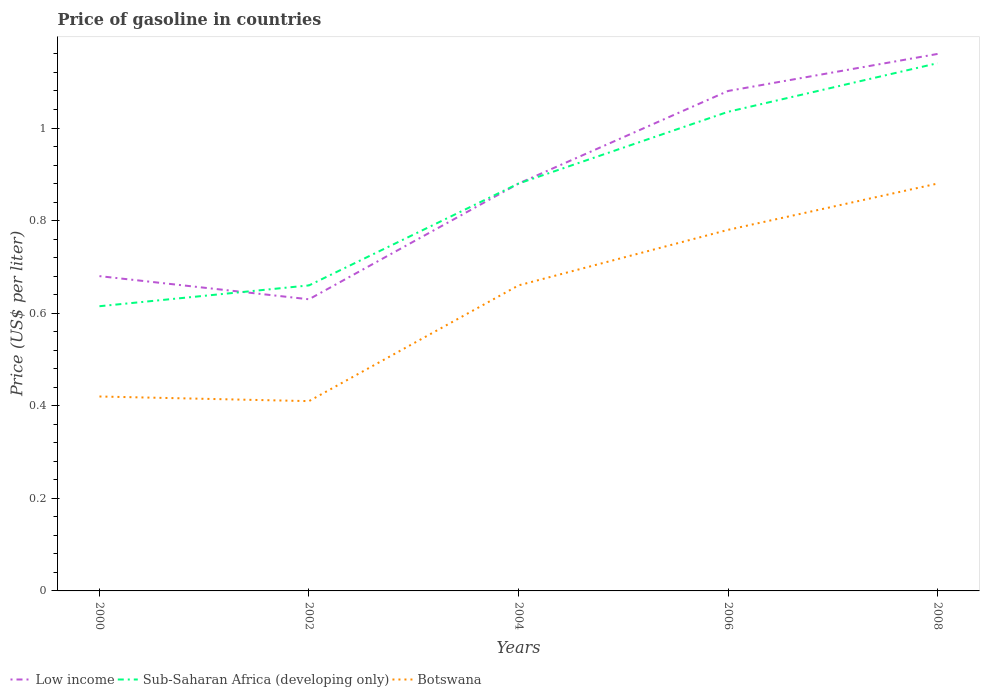Does the line corresponding to Botswana intersect with the line corresponding to Low income?
Offer a very short reply. No. Is the number of lines equal to the number of legend labels?
Keep it short and to the point. Yes. Across all years, what is the maximum price of gasoline in Sub-Saharan Africa (developing only)?
Your response must be concise. 0.61. What is the total price of gasoline in Sub-Saharan Africa (developing only) in the graph?
Keep it short and to the point. -0.05. What is the difference between the highest and the second highest price of gasoline in Sub-Saharan Africa (developing only)?
Provide a succinct answer. 0.52. What is the difference between the highest and the lowest price of gasoline in Sub-Saharan Africa (developing only)?
Your answer should be compact. 3. How many lines are there?
Ensure brevity in your answer.  3. What is the difference between two consecutive major ticks on the Y-axis?
Your response must be concise. 0.2. Where does the legend appear in the graph?
Your answer should be very brief. Bottom left. How are the legend labels stacked?
Your response must be concise. Horizontal. What is the title of the graph?
Your answer should be very brief. Price of gasoline in countries. What is the label or title of the X-axis?
Your response must be concise. Years. What is the label or title of the Y-axis?
Your answer should be very brief. Price (US$ per liter). What is the Price (US$ per liter) of Low income in 2000?
Your response must be concise. 0.68. What is the Price (US$ per liter) in Sub-Saharan Africa (developing only) in 2000?
Offer a terse response. 0.61. What is the Price (US$ per liter) of Botswana in 2000?
Make the answer very short. 0.42. What is the Price (US$ per liter) of Low income in 2002?
Give a very brief answer. 0.63. What is the Price (US$ per liter) of Sub-Saharan Africa (developing only) in 2002?
Your answer should be compact. 0.66. What is the Price (US$ per liter) in Botswana in 2002?
Provide a short and direct response. 0.41. What is the Price (US$ per liter) of Low income in 2004?
Provide a succinct answer. 0.88. What is the Price (US$ per liter) in Sub-Saharan Africa (developing only) in 2004?
Your response must be concise. 0.88. What is the Price (US$ per liter) in Botswana in 2004?
Ensure brevity in your answer.  0.66. What is the Price (US$ per liter) in Low income in 2006?
Keep it short and to the point. 1.08. What is the Price (US$ per liter) of Sub-Saharan Africa (developing only) in 2006?
Your answer should be compact. 1.03. What is the Price (US$ per liter) of Botswana in 2006?
Offer a very short reply. 0.78. What is the Price (US$ per liter) in Low income in 2008?
Keep it short and to the point. 1.16. What is the Price (US$ per liter) of Sub-Saharan Africa (developing only) in 2008?
Offer a terse response. 1.14. Across all years, what is the maximum Price (US$ per liter) of Low income?
Ensure brevity in your answer.  1.16. Across all years, what is the maximum Price (US$ per liter) of Sub-Saharan Africa (developing only)?
Provide a short and direct response. 1.14. Across all years, what is the minimum Price (US$ per liter) of Low income?
Your answer should be very brief. 0.63. Across all years, what is the minimum Price (US$ per liter) in Sub-Saharan Africa (developing only)?
Give a very brief answer. 0.61. Across all years, what is the minimum Price (US$ per liter) of Botswana?
Keep it short and to the point. 0.41. What is the total Price (US$ per liter) in Low income in the graph?
Provide a short and direct response. 4.43. What is the total Price (US$ per liter) of Sub-Saharan Africa (developing only) in the graph?
Provide a short and direct response. 4.33. What is the total Price (US$ per liter) of Botswana in the graph?
Offer a terse response. 3.15. What is the difference between the Price (US$ per liter) in Sub-Saharan Africa (developing only) in 2000 and that in 2002?
Offer a terse response. -0.04. What is the difference between the Price (US$ per liter) in Botswana in 2000 and that in 2002?
Provide a short and direct response. 0.01. What is the difference between the Price (US$ per liter) of Sub-Saharan Africa (developing only) in 2000 and that in 2004?
Ensure brevity in your answer.  -0.27. What is the difference between the Price (US$ per liter) in Botswana in 2000 and that in 2004?
Keep it short and to the point. -0.24. What is the difference between the Price (US$ per liter) of Low income in 2000 and that in 2006?
Offer a very short reply. -0.4. What is the difference between the Price (US$ per liter) of Sub-Saharan Africa (developing only) in 2000 and that in 2006?
Make the answer very short. -0.42. What is the difference between the Price (US$ per liter) in Botswana in 2000 and that in 2006?
Give a very brief answer. -0.36. What is the difference between the Price (US$ per liter) of Low income in 2000 and that in 2008?
Ensure brevity in your answer.  -0.48. What is the difference between the Price (US$ per liter) in Sub-Saharan Africa (developing only) in 2000 and that in 2008?
Offer a very short reply. -0.53. What is the difference between the Price (US$ per liter) of Botswana in 2000 and that in 2008?
Provide a succinct answer. -0.46. What is the difference between the Price (US$ per liter) in Sub-Saharan Africa (developing only) in 2002 and that in 2004?
Give a very brief answer. -0.22. What is the difference between the Price (US$ per liter) in Low income in 2002 and that in 2006?
Your answer should be compact. -0.45. What is the difference between the Price (US$ per liter) of Sub-Saharan Africa (developing only) in 2002 and that in 2006?
Keep it short and to the point. -0.38. What is the difference between the Price (US$ per liter) of Botswana in 2002 and that in 2006?
Make the answer very short. -0.37. What is the difference between the Price (US$ per liter) in Low income in 2002 and that in 2008?
Your answer should be compact. -0.53. What is the difference between the Price (US$ per liter) in Sub-Saharan Africa (developing only) in 2002 and that in 2008?
Your response must be concise. -0.48. What is the difference between the Price (US$ per liter) of Botswana in 2002 and that in 2008?
Provide a short and direct response. -0.47. What is the difference between the Price (US$ per liter) in Low income in 2004 and that in 2006?
Your response must be concise. -0.2. What is the difference between the Price (US$ per liter) in Sub-Saharan Africa (developing only) in 2004 and that in 2006?
Keep it short and to the point. -0.15. What is the difference between the Price (US$ per liter) of Botswana in 2004 and that in 2006?
Give a very brief answer. -0.12. What is the difference between the Price (US$ per liter) of Low income in 2004 and that in 2008?
Provide a short and direct response. -0.28. What is the difference between the Price (US$ per liter) in Sub-Saharan Africa (developing only) in 2004 and that in 2008?
Offer a very short reply. -0.26. What is the difference between the Price (US$ per liter) in Botswana in 2004 and that in 2008?
Provide a succinct answer. -0.22. What is the difference between the Price (US$ per liter) of Low income in 2006 and that in 2008?
Your response must be concise. -0.08. What is the difference between the Price (US$ per liter) of Sub-Saharan Africa (developing only) in 2006 and that in 2008?
Offer a very short reply. -0.1. What is the difference between the Price (US$ per liter) of Botswana in 2006 and that in 2008?
Offer a very short reply. -0.1. What is the difference between the Price (US$ per liter) in Low income in 2000 and the Price (US$ per liter) in Sub-Saharan Africa (developing only) in 2002?
Your answer should be compact. 0.02. What is the difference between the Price (US$ per liter) of Low income in 2000 and the Price (US$ per liter) of Botswana in 2002?
Make the answer very short. 0.27. What is the difference between the Price (US$ per liter) of Sub-Saharan Africa (developing only) in 2000 and the Price (US$ per liter) of Botswana in 2002?
Your answer should be very brief. 0.2. What is the difference between the Price (US$ per liter) in Low income in 2000 and the Price (US$ per liter) in Botswana in 2004?
Ensure brevity in your answer.  0.02. What is the difference between the Price (US$ per liter) in Sub-Saharan Africa (developing only) in 2000 and the Price (US$ per liter) in Botswana in 2004?
Keep it short and to the point. -0.04. What is the difference between the Price (US$ per liter) of Low income in 2000 and the Price (US$ per liter) of Sub-Saharan Africa (developing only) in 2006?
Provide a short and direct response. -0.35. What is the difference between the Price (US$ per liter) of Low income in 2000 and the Price (US$ per liter) of Botswana in 2006?
Provide a succinct answer. -0.1. What is the difference between the Price (US$ per liter) of Sub-Saharan Africa (developing only) in 2000 and the Price (US$ per liter) of Botswana in 2006?
Provide a succinct answer. -0.17. What is the difference between the Price (US$ per liter) in Low income in 2000 and the Price (US$ per liter) in Sub-Saharan Africa (developing only) in 2008?
Provide a succinct answer. -0.46. What is the difference between the Price (US$ per liter) in Sub-Saharan Africa (developing only) in 2000 and the Price (US$ per liter) in Botswana in 2008?
Provide a short and direct response. -0.27. What is the difference between the Price (US$ per liter) in Low income in 2002 and the Price (US$ per liter) in Sub-Saharan Africa (developing only) in 2004?
Your answer should be compact. -0.25. What is the difference between the Price (US$ per liter) in Low income in 2002 and the Price (US$ per liter) in Botswana in 2004?
Give a very brief answer. -0.03. What is the difference between the Price (US$ per liter) in Low income in 2002 and the Price (US$ per liter) in Sub-Saharan Africa (developing only) in 2006?
Make the answer very short. -0.41. What is the difference between the Price (US$ per liter) in Low income in 2002 and the Price (US$ per liter) in Botswana in 2006?
Your response must be concise. -0.15. What is the difference between the Price (US$ per liter) in Sub-Saharan Africa (developing only) in 2002 and the Price (US$ per liter) in Botswana in 2006?
Make the answer very short. -0.12. What is the difference between the Price (US$ per liter) in Low income in 2002 and the Price (US$ per liter) in Sub-Saharan Africa (developing only) in 2008?
Offer a terse response. -0.51. What is the difference between the Price (US$ per liter) in Low income in 2002 and the Price (US$ per liter) in Botswana in 2008?
Give a very brief answer. -0.25. What is the difference between the Price (US$ per liter) in Sub-Saharan Africa (developing only) in 2002 and the Price (US$ per liter) in Botswana in 2008?
Offer a terse response. -0.22. What is the difference between the Price (US$ per liter) in Low income in 2004 and the Price (US$ per liter) in Sub-Saharan Africa (developing only) in 2006?
Your answer should be very brief. -0.15. What is the difference between the Price (US$ per liter) in Sub-Saharan Africa (developing only) in 2004 and the Price (US$ per liter) in Botswana in 2006?
Ensure brevity in your answer.  0.1. What is the difference between the Price (US$ per liter) in Low income in 2004 and the Price (US$ per liter) in Sub-Saharan Africa (developing only) in 2008?
Your answer should be very brief. -0.26. What is the difference between the Price (US$ per liter) in Low income in 2004 and the Price (US$ per liter) in Botswana in 2008?
Your answer should be very brief. 0. What is the difference between the Price (US$ per liter) of Low income in 2006 and the Price (US$ per liter) of Sub-Saharan Africa (developing only) in 2008?
Your answer should be very brief. -0.06. What is the difference between the Price (US$ per liter) of Low income in 2006 and the Price (US$ per liter) of Botswana in 2008?
Keep it short and to the point. 0.2. What is the difference between the Price (US$ per liter) in Sub-Saharan Africa (developing only) in 2006 and the Price (US$ per liter) in Botswana in 2008?
Your response must be concise. 0.15. What is the average Price (US$ per liter) in Low income per year?
Keep it short and to the point. 0.89. What is the average Price (US$ per liter) in Sub-Saharan Africa (developing only) per year?
Offer a very short reply. 0.87. What is the average Price (US$ per liter) in Botswana per year?
Your answer should be very brief. 0.63. In the year 2000, what is the difference between the Price (US$ per liter) in Low income and Price (US$ per liter) in Sub-Saharan Africa (developing only)?
Make the answer very short. 0.07. In the year 2000, what is the difference between the Price (US$ per liter) of Low income and Price (US$ per liter) of Botswana?
Provide a succinct answer. 0.26. In the year 2000, what is the difference between the Price (US$ per liter) in Sub-Saharan Africa (developing only) and Price (US$ per liter) in Botswana?
Offer a very short reply. 0.2. In the year 2002, what is the difference between the Price (US$ per liter) in Low income and Price (US$ per liter) in Sub-Saharan Africa (developing only)?
Ensure brevity in your answer.  -0.03. In the year 2002, what is the difference between the Price (US$ per liter) in Low income and Price (US$ per liter) in Botswana?
Provide a short and direct response. 0.22. In the year 2002, what is the difference between the Price (US$ per liter) of Sub-Saharan Africa (developing only) and Price (US$ per liter) of Botswana?
Your answer should be very brief. 0.25. In the year 2004, what is the difference between the Price (US$ per liter) in Low income and Price (US$ per liter) in Sub-Saharan Africa (developing only)?
Give a very brief answer. 0. In the year 2004, what is the difference between the Price (US$ per liter) of Low income and Price (US$ per liter) of Botswana?
Offer a terse response. 0.22. In the year 2004, what is the difference between the Price (US$ per liter) in Sub-Saharan Africa (developing only) and Price (US$ per liter) in Botswana?
Keep it short and to the point. 0.22. In the year 2006, what is the difference between the Price (US$ per liter) in Low income and Price (US$ per liter) in Sub-Saharan Africa (developing only)?
Your response must be concise. 0.04. In the year 2006, what is the difference between the Price (US$ per liter) of Sub-Saharan Africa (developing only) and Price (US$ per liter) of Botswana?
Keep it short and to the point. 0.26. In the year 2008, what is the difference between the Price (US$ per liter) of Low income and Price (US$ per liter) of Botswana?
Offer a very short reply. 0.28. In the year 2008, what is the difference between the Price (US$ per liter) in Sub-Saharan Africa (developing only) and Price (US$ per liter) in Botswana?
Make the answer very short. 0.26. What is the ratio of the Price (US$ per liter) in Low income in 2000 to that in 2002?
Your answer should be compact. 1.08. What is the ratio of the Price (US$ per liter) of Sub-Saharan Africa (developing only) in 2000 to that in 2002?
Offer a very short reply. 0.93. What is the ratio of the Price (US$ per liter) in Botswana in 2000 to that in 2002?
Offer a terse response. 1.02. What is the ratio of the Price (US$ per liter) of Low income in 2000 to that in 2004?
Provide a succinct answer. 0.77. What is the ratio of the Price (US$ per liter) in Sub-Saharan Africa (developing only) in 2000 to that in 2004?
Make the answer very short. 0.7. What is the ratio of the Price (US$ per liter) of Botswana in 2000 to that in 2004?
Give a very brief answer. 0.64. What is the ratio of the Price (US$ per liter) of Low income in 2000 to that in 2006?
Make the answer very short. 0.63. What is the ratio of the Price (US$ per liter) in Sub-Saharan Africa (developing only) in 2000 to that in 2006?
Ensure brevity in your answer.  0.59. What is the ratio of the Price (US$ per liter) of Botswana in 2000 to that in 2006?
Keep it short and to the point. 0.54. What is the ratio of the Price (US$ per liter) in Low income in 2000 to that in 2008?
Your answer should be compact. 0.59. What is the ratio of the Price (US$ per liter) in Sub-Saharan Africa (developing only) in 2000 to that in 2008?
Offer a terse response. 0.54. What is the ratio of the Price (US$ per liter) in Botswana in 2000 to that in 2008?
Provide a succinct answer. 0.48. What is the ratio of the Price (US$ per liter) of Low income in 2002 to that in 2004?
Your response must be concise. 0.72. What is the ratio of the Price (US$ per liter) in Botswana in 2002 to that in 2004?
Ensure brevity in your answer.  0.62. What is the ratio of the Price (US$ per liter) of Low income in 2002 to that in 2006?
Provide a succinct answer. 0.58. What is the ratio of the Price (US$ per liter) of Sub-Saharan Africa (developing only) in 2002 to that in 2006?
Offer a very short reply. 0.64. What is the ratio of the Price (US$ per liter) in Botswana in 2002 to that in 2006?
Offer a terse response. 0.53. What is the ratio of the Price (US$ per liter) in Low income in 2002 to that in 2008?
Your answer should be very brief. 0.54. What is the ratio of the Price (US$ per liter) in Sub-Saharan Africa (developing only) in 2002 to that in 2008?
Your answer should be very brief. 0.58. What is the ratio of the Price (US$ per liter) of Botswana in 2002 to that in 2008?
Provide a succinct answer. 0.47. What is the ratio of the Price (US$ per liter) of Low income in 2004 to that in 2006?
Your answer should be compact. 0.81. What is the ratio of the Price (US$ per liter) of Sub-Saharan Africa (developing only) in 2004 to that in 2006?
Offer a very short reply. 0.85. What is the ratio of the Price (US$ per liter) of Botswana in 2004 to that in 2006?
Ensure brevity in your answer.  0.85. What is the ratio of the Price (US$ per liter) in Low income in 2004 to that in 2008?
Your response must be concise. 0.76. What is the ratio of the Price (US$ per liter) of Sub-Saharan Africa (developing only) in 2004 to that in 2008?
Offer a very short reply. 0.77. What is the ratio of the Price (US$ per liter) of Botswana in 2004 to that in 2008?
Give a very brief answer. 0.75. What is the ratio of the Price (US$ per liter) of Low income in 2006 to that in 2008?
Your answer should be very brief. 0.93. What is the ratio of the Price (US$ per liter) in Sub-Saharan Africa (developing only) in 2006 to that in 2008?
Make the answer very short. 0.91. What is the ratio of the Price (US$ per liter) of Botswana in 2006 to that in 2008?
Offer a terse response. 0.89. What is the difference between the highest and the second highest Price (US$ per liter) in Sub-Saharan Africa (developing only)?
Ensure brevity in your answer.  0.1. What is the difference between the highest and the second highest Price (US$ per liter) of Botswana?
Give a very brief answer. 0.1. What is the difference between the highest and the lowest Price (US$ per liter) in Low income?
Provide a succinct answer. 0.53. What is the difference between the highest and the lowest Price (US$ per liter) of Sub-Saharan Africa (developing only)?
Make the answer very short. 0.53. What is the difference between the highest and the lowest Price (US$ per liter) of Botswana?
Offer a terse response. 0.47. 